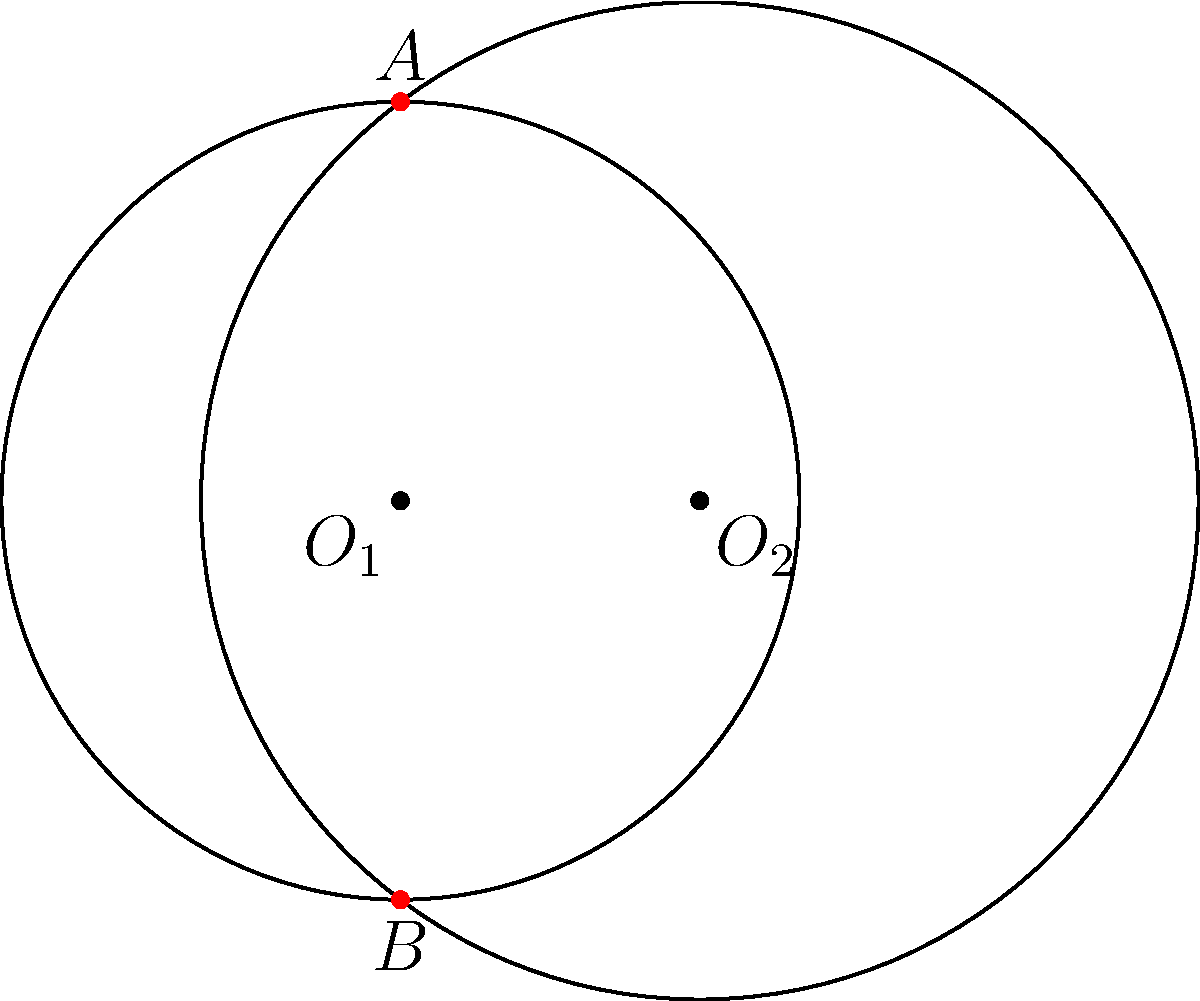In your latest cake design, you've created two circular cake layers that partially overlap. The centers of the layers are 3 units apart on a horizontal line. The radius of the first layer (centered at $O_1$) is 4 units, while the radius of the second layer (centered at $O_2$) is 5 units. Find the y-coordinates of the intersection points A and B where the layers overlap. Let's approach this step-by-step:

1) We can represent the two circles with equations:
   Circle 1: $x^2 + y^2 = 16$ (center at (0,0), radius 4)
   Circle 2: $(x-3)^2 + y^2 = 25$ (center at (3,0), radius 5)

2) To find the intersection points, we need to solve these equations simultaneously.

3) Expanding the second equation:
   $x^2 - 6x + 9 + y^2 = 25$

4) Subtracting the first equation from this:
   $-6x + 9 = 9$
   $-6x = 0$
   $x = 0$

5) This means the intersection points have an x-coordinate of 0.

6) Substituting this back into the equation of the first circle:
   $0^2 + y^2 = 16$
   $y^2 = 16$
   $y = \pm 4$

7) Therefore, the intersection points are (0,4) and (0,-4).

8) The y-coordinates of the intersection points A and B are 4 and -4 respectively.
Answer: 4 and -4 